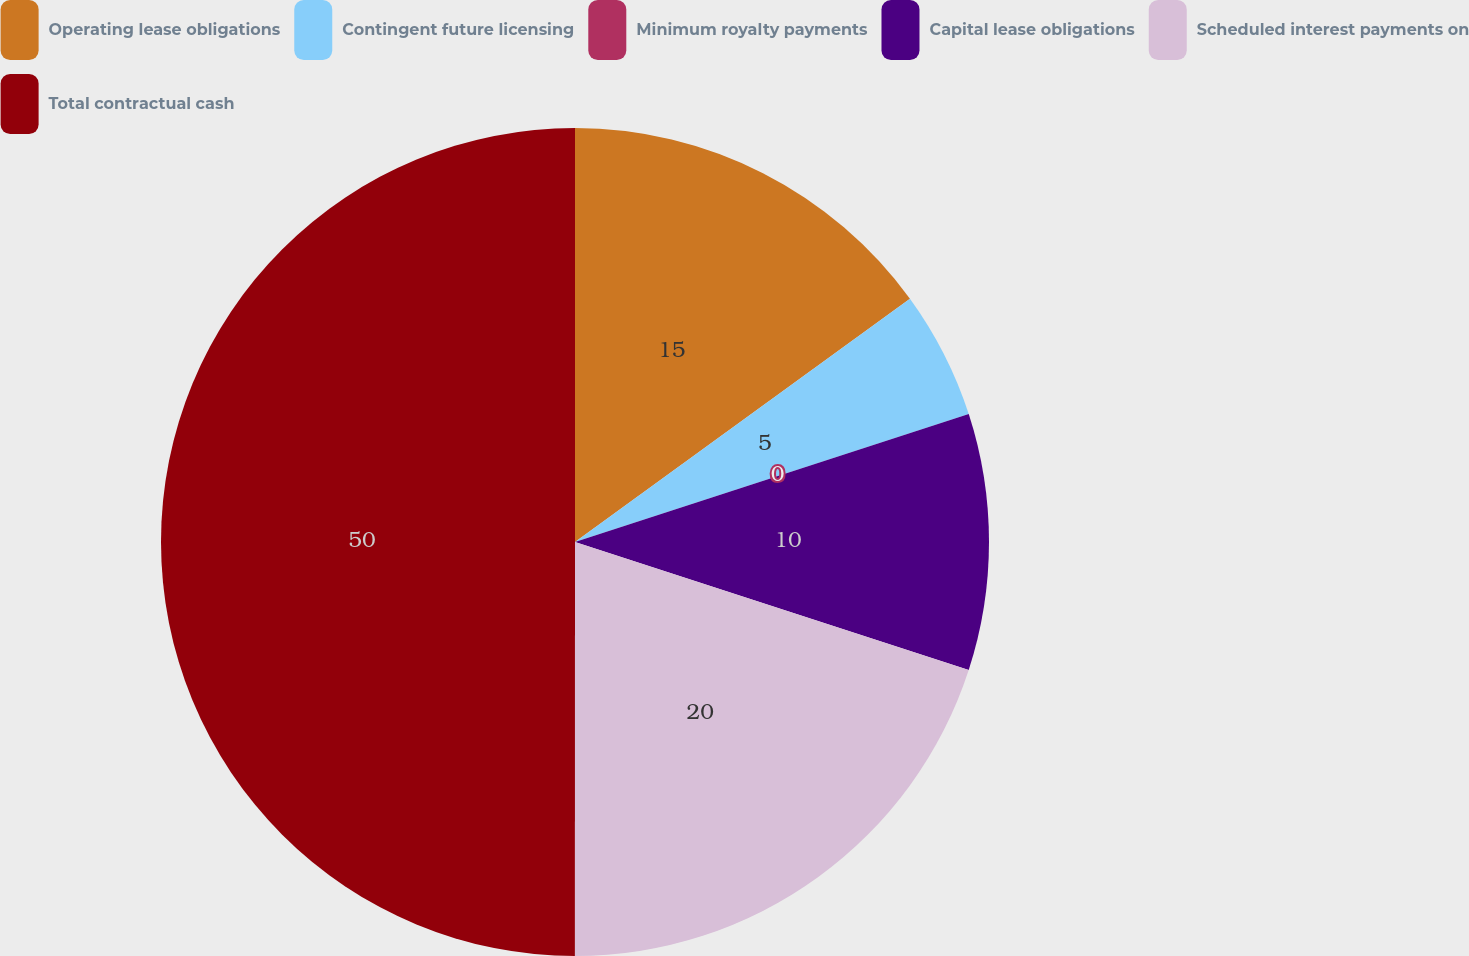<chart> <loc_0><loc_0><loc_500><loc_500><pie_chart><fcel>Operating lease obligations<fcel>Contingent future licensing<fcel>Minimum royalty payments<fcel>Capital lease obligations<fcel>Scheduled interest payments on<fcel>Total contractual cash<nl><fcel>15.0%<fcel>5.0%<fcel>0.0%<fcel>10.0%<fcel>20.0%<fcel>49.99%<nl></chart> 